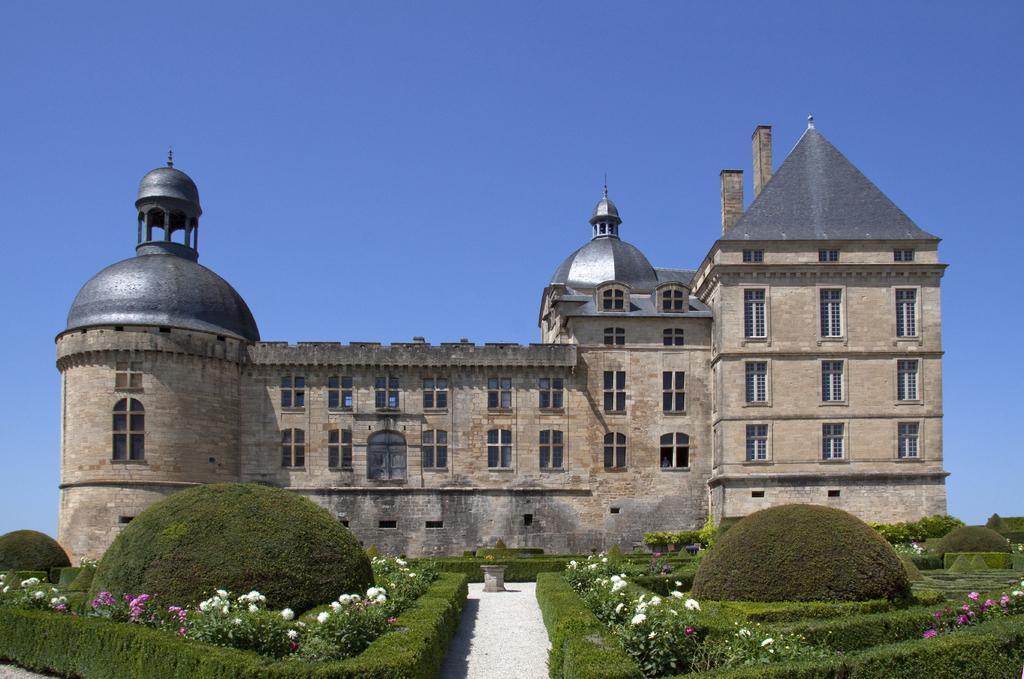Describe this image in one or two sentences. In the picture we can see a huge building with many windows to it and near it, we can see a garden with full of plants and flowers which are pink and white in color and in the background we can see a sky. 